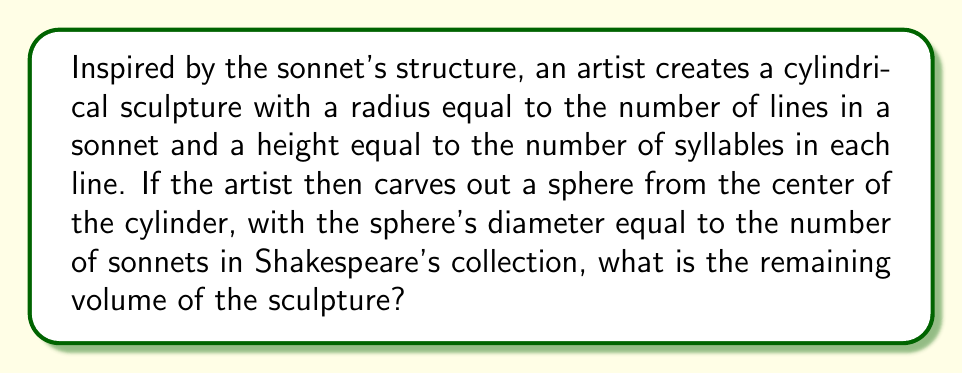Show me your answer to this math problem. Let's approach this step-by-step:

1. Recall the dimensions:
   - Sonnet has 14 lines, so radius (r) = 14 cm
   - Each line has 10 syllables, so height (h) = 10 cm
   - Shakespeare wrote 154 sonnets, so sphere diameter = 154 cm, radius (R) = 77 cm

2. Calculate the volume of the cylinder:
   $$V_{cylinder} = \pi r^2 h = \pi \cdot 14^2 \cdot 10 = 6160\pi \text{ cm}^3$$

3. Calculate the volume of the sphere:
   $$V_{sphere} = \frac{4}{3}\pi R^3 = \frac{4}{3}\pi \cdot 77^3 = \frac{1815848}{3}\pi \text{ cm}^3$$

4. Check if the sphere fits within the cylinder:
   The sphere's diameter (154 cm) is greater than both the cylinder's diameter (28 cm) and height (10 cm), so it doesn't fit entirely.

5. Calculate the volume of the sphere segment that fits within the cylinder:
   Using the formula for a sphere cap:
   $$V_{cap} = \frac{1}{3}\pi h^2(3R - h)$$
   where h is the height of the cap (5 cm, half of the cylinder's height)
   $$V_{cap} = \frac{1}{3}\pi \cdot 5^2(3 \cdot 77 - 5) = \frac{28750}{3}\pi \text{ cm}^3$$

6. Calculate the remaining volume:
   $$V_{remaining} = V_{cylinder} - V_{cap} = 6160\pi - \frac{28750}{3}\pi = \frac{9730}{3}\pi \text{ cm}^3$$

[asy]
import three;

size(200);
currentprojection=perspective(6,3,2);

draw(cylinder((0,0,0),7,5),blue);
draw(sphere((0,0,0),38.5),red+opacity(0.5));
[/asy]
Answer: $\frac{9730}{3}\pi \text{ cm}^3$ 